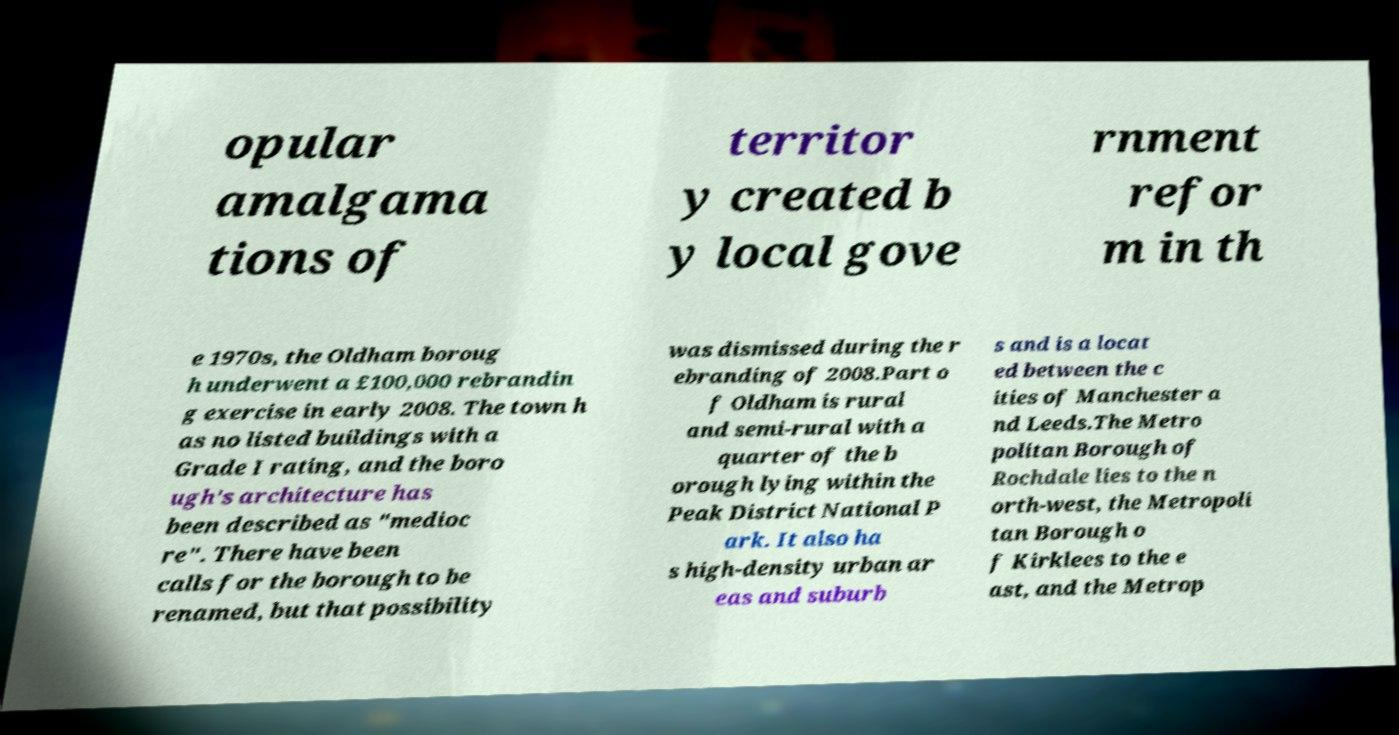There's text embedded in this image that I need extracted. Can you transcribe it verbatim? opular amalgama tions of territor y created b y local gove rnment refor m in th e 1970s, the Oldham boroug h underwent a £100,000 rebrandin g exercise in early 2008. The town h as no listed buildings with a Grade I rating, and the boro ugh's architecture has been described as "medioc re". There have been calls for the borough to be renamed, but that possibility was dismissed during the r ebranding of 2008.Part o f Oldham is rural and semi-rural with a quarter of the b orough lying within the Peak District National P ark. It also ha s high-density urban ar eas and suburb s and is a locat ed between the c ities of Manchester a nd Leeds.The Metro politan Borough of Rochdale lies to the n orth-west, the Metropoli tan Borough o f Kirklees to the e ast, and the Metrop 